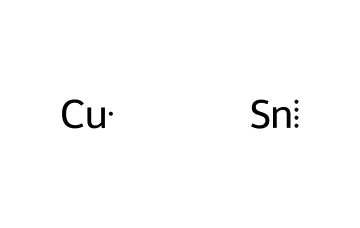What is the main metal component in bronze? The SMILES notation indicates copper (Cu) as a primary element, which is a significant component in bronze.
Answer: copper How many different elements are present in this bronze structure? The SMILES representation shows two distinct elements: copper (Cu) and tin (Sn). Hence, there are two different elements.
Answer: two What type of bond exists between the elements in this chemical structure? In the context of the SMILES representation, the elements are presented separately, indicating that they are not covalently bonded but rather exist in an alloy form, which is typical for metal mixtures like bronze.
Answer: metallic What is the role of tin in bronze metallurgy? Tin, as depicted in the structure, is known to provide strength and corrosion resistance to bronze, enhancing its overall properties compared to pure copper.
Answer: alloying How does the composition of bronze vary with copper and tin ratios? The ratios of copper and tin directly affect the properties of bronze, such as hardness and melting point, with varying percentages leading to different types of bronze, such as tin bronze or lead bronze.
Answer: varying properties Can this structure undergo oxidation? Yes, bronze can undergo oxidation, especially under certain conditions, leading to patina formation, as copper oxides develop on the surface.
Answer: yes 